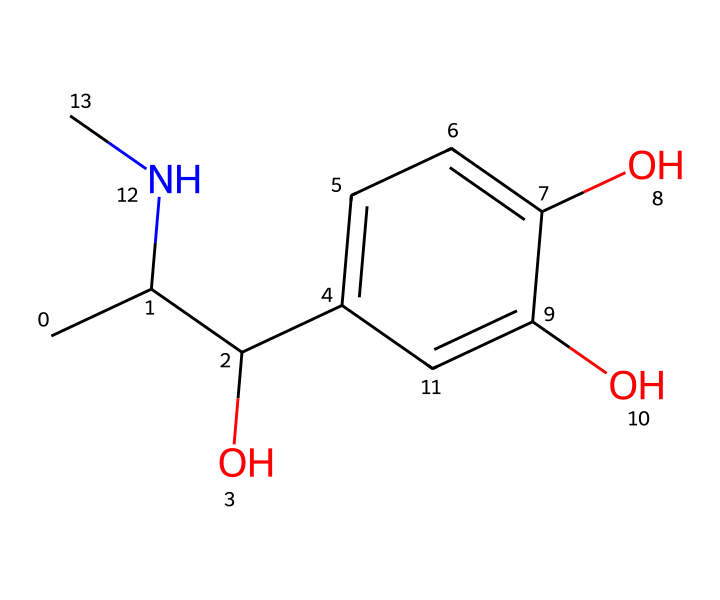What is the chemical name of the compound represented by the SMILES? The SMILES structure corresponds to epinephrine, which is also known as adrenaline. The 'CC(C(O)c1ccc(O)c(O)c1)NC' indicates its specific structure as a chiral molecule with a benzene ring and hydroxyl groups.
Answer: epinephrine How many chiral centers are present in epinephrine? By analyzing the structure, there are two carbon atoms that are bonded to four different substituents, qualifying them as chiral centers. This allows for the existence of enantiomers.
Answer: two What functional groups are present in the epinephrine structure? The SMILES reveals several functional groups: a hydroxyl group (-OH) and an amine group (-NH). These are significant in determining the compound's reactivity and solubility.
Answer: hydroxyl and amine Which enantiomer of epinephrine is more commonly used in dental emergencies? The R-enantiomer (right-handed twist) of epinephrine is primarily utilized due to its greater biological activity in stimulating adrenergic receptors, making it more effective in emergency situations.
Answer: R-enantiomer How does the chirality of epinephrine affect its biological activity? Chirality in molecules like epinephrine leads to distinct interactions with biological receptors; the specific spatial arrangement affects binding affinity and subsequent physiological effects, with different enantiomers eliciting varying responses.
Answer: affects binding affinity What role does epinephrine play during dental procedures? Epinephrine is commonly used as a vasoconstrictor to reduce bleeding during dental procedures and to prolong the effects of anesthesia, making it crucial for patient management.
Answer: vasoconstrictor 